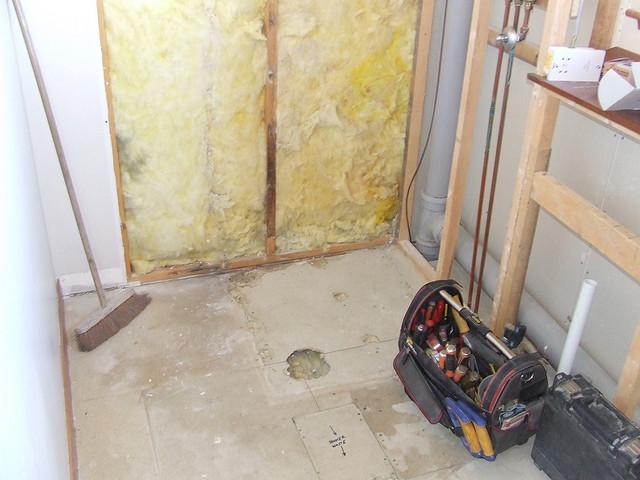What is the yellow stuff on the side wall?
Give a very brief answer. Insulation. What is leaning in the left corner?
Keep it brief. Broom. What needs to be done to complete this project?
Write a very short answer. Hang drywall. 